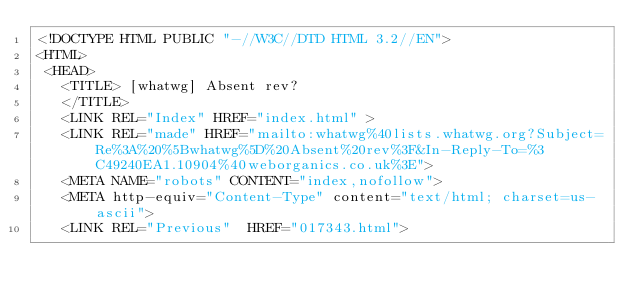<code> <loc_0><loc_0><loc_500><loc_500><_HTML_><!DOCTYPE HTML PUBLIC "-//W3C//DTD HTML 3.2//EN">
<HTML>
 <HEAD>
   <TITLE> [whatwg] Absent rev?
   </TITLE>
   <LINK REL="Index" HREF="index.html" >
   <LINK REL="made" HREF="mailto:whatwg%40lists.whatwg.org?Subject=Re%3A%20%5Bwhatwg%5D%20Absent%20rev%3F&In-Reply-To=%3C49240EA1.10904%40weborganics.co.uk%3E">
   <META NAME="robots" CONTENT="index,nofollow">
   <META http-equiv="Content-Type" content="text/html; charset=us-ascii">
   <LINK REL="Previous"  HREF="017343.html"></code> 